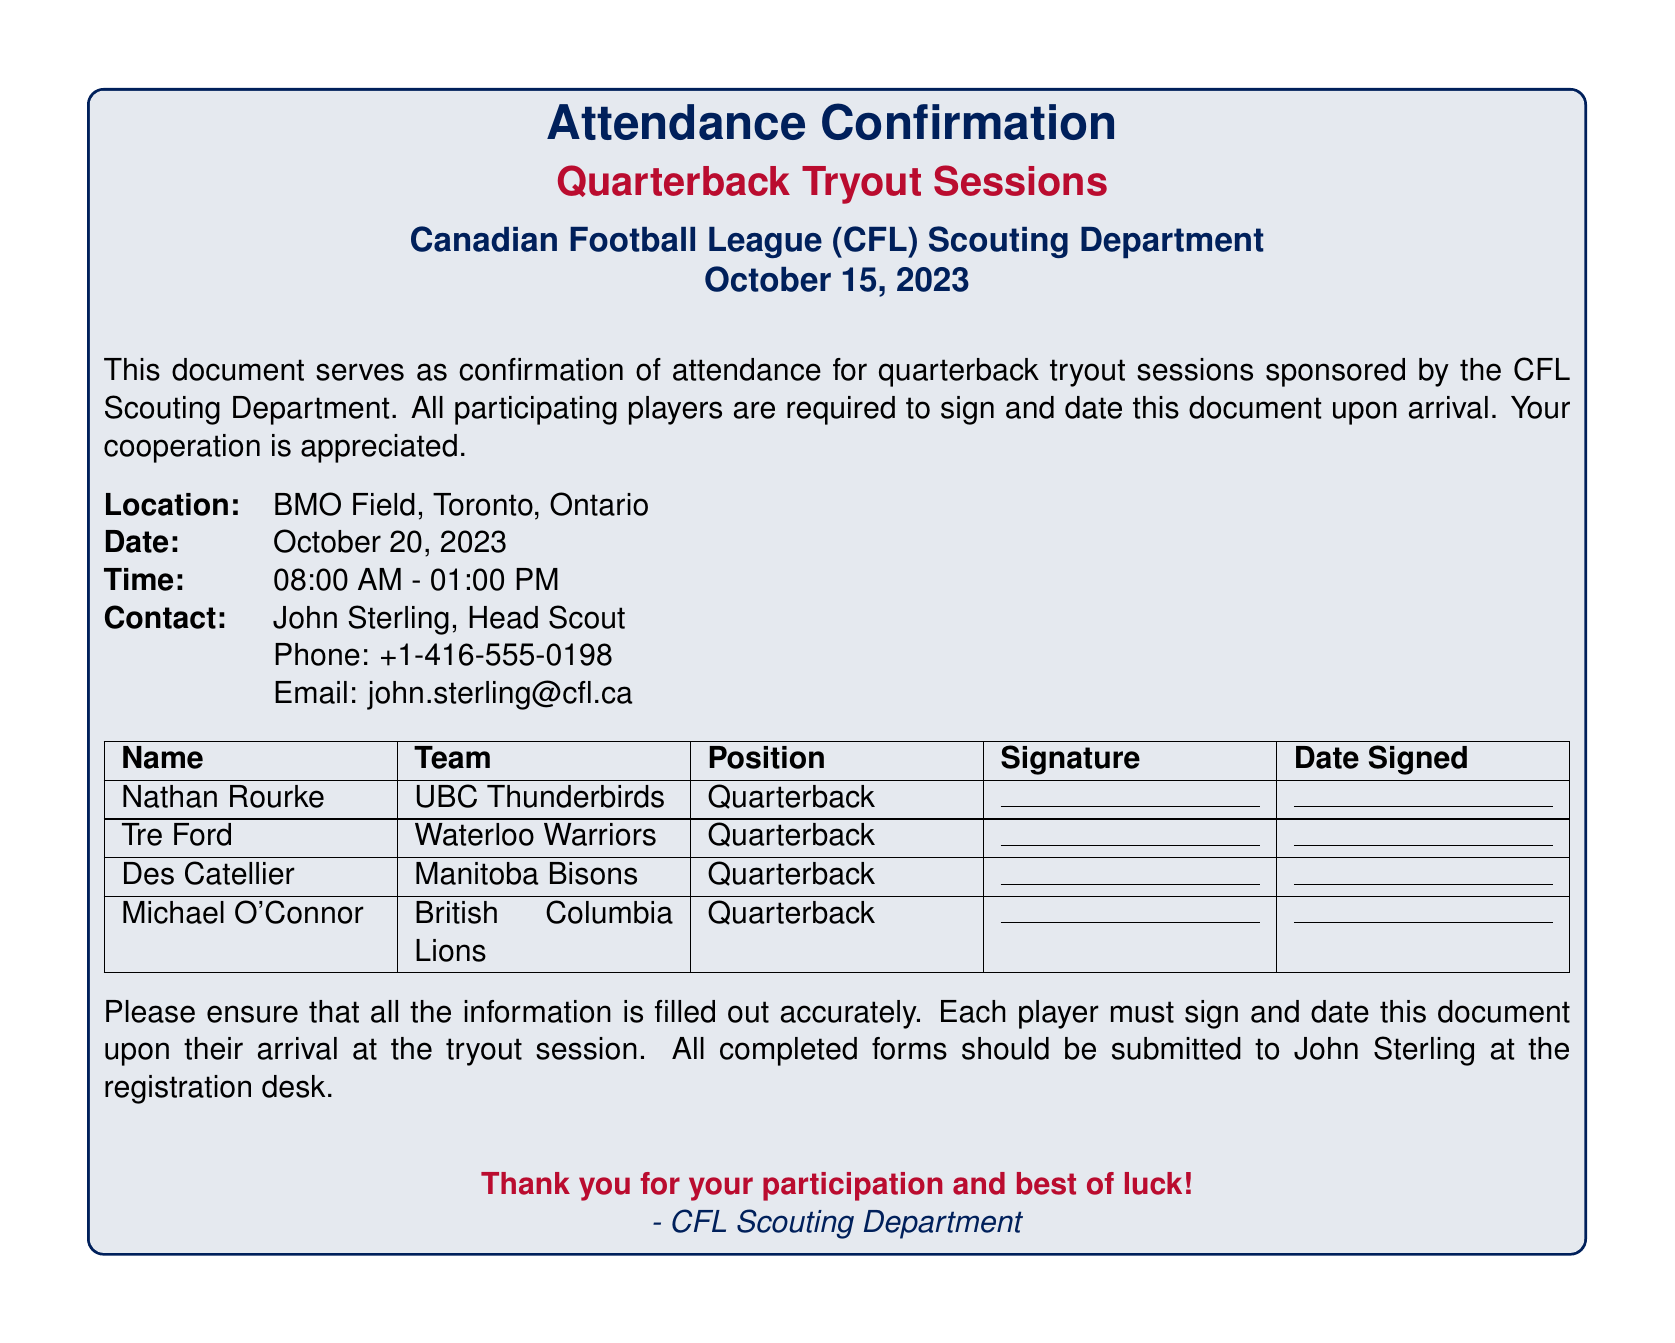What is the location of the tryout sessions? The location is specified in the document, stating that the sessions will occur at BMO Field, Toronto, Ontario.
Answer: BMO Field, Toronto, Ontario What is the date of the tryout sessions? The document clearly states the date of the quarterback tryout sessions.
Answer: October 20, 2023 Who is the head scout for the event? The document mentions John Sterling as the Head Scout for the tryout sessions.
Answer: John Sterling What time do the tryout sessions start? The time of the sessions is indicated in the document, specifically stating the start time.
Answer: 08:00 AM How many players are participating as listed in the document? The document lists four players in the section dedicated to signatures.
Answer: Four What team does Nathan Rourke play for? Nathan Rourke's associated team is mentioned in the document.
Answer: UBC Thunderbirds What type of sessions is this document confirming? The document specifies that it is confirming attendance for quarterback tryout sessions.
Answer: Quarterback Tryout Sessions What must players do upon arrival according to the document? The document states that all participating players are required to sign and date the document upon arrival.
Answer: Sign and date the document What is the contact email provided for inquiries? The document includes John Sterling's email address for contact.
Answer: john.sterling@cfl.ca 